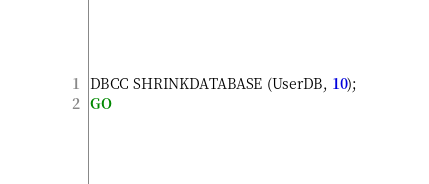<code> <loc_0><loc_0><loc_500><loc_500><_SQL_>DBCC SHRINKDATABASE (UserDB, 10);
GO</code> 